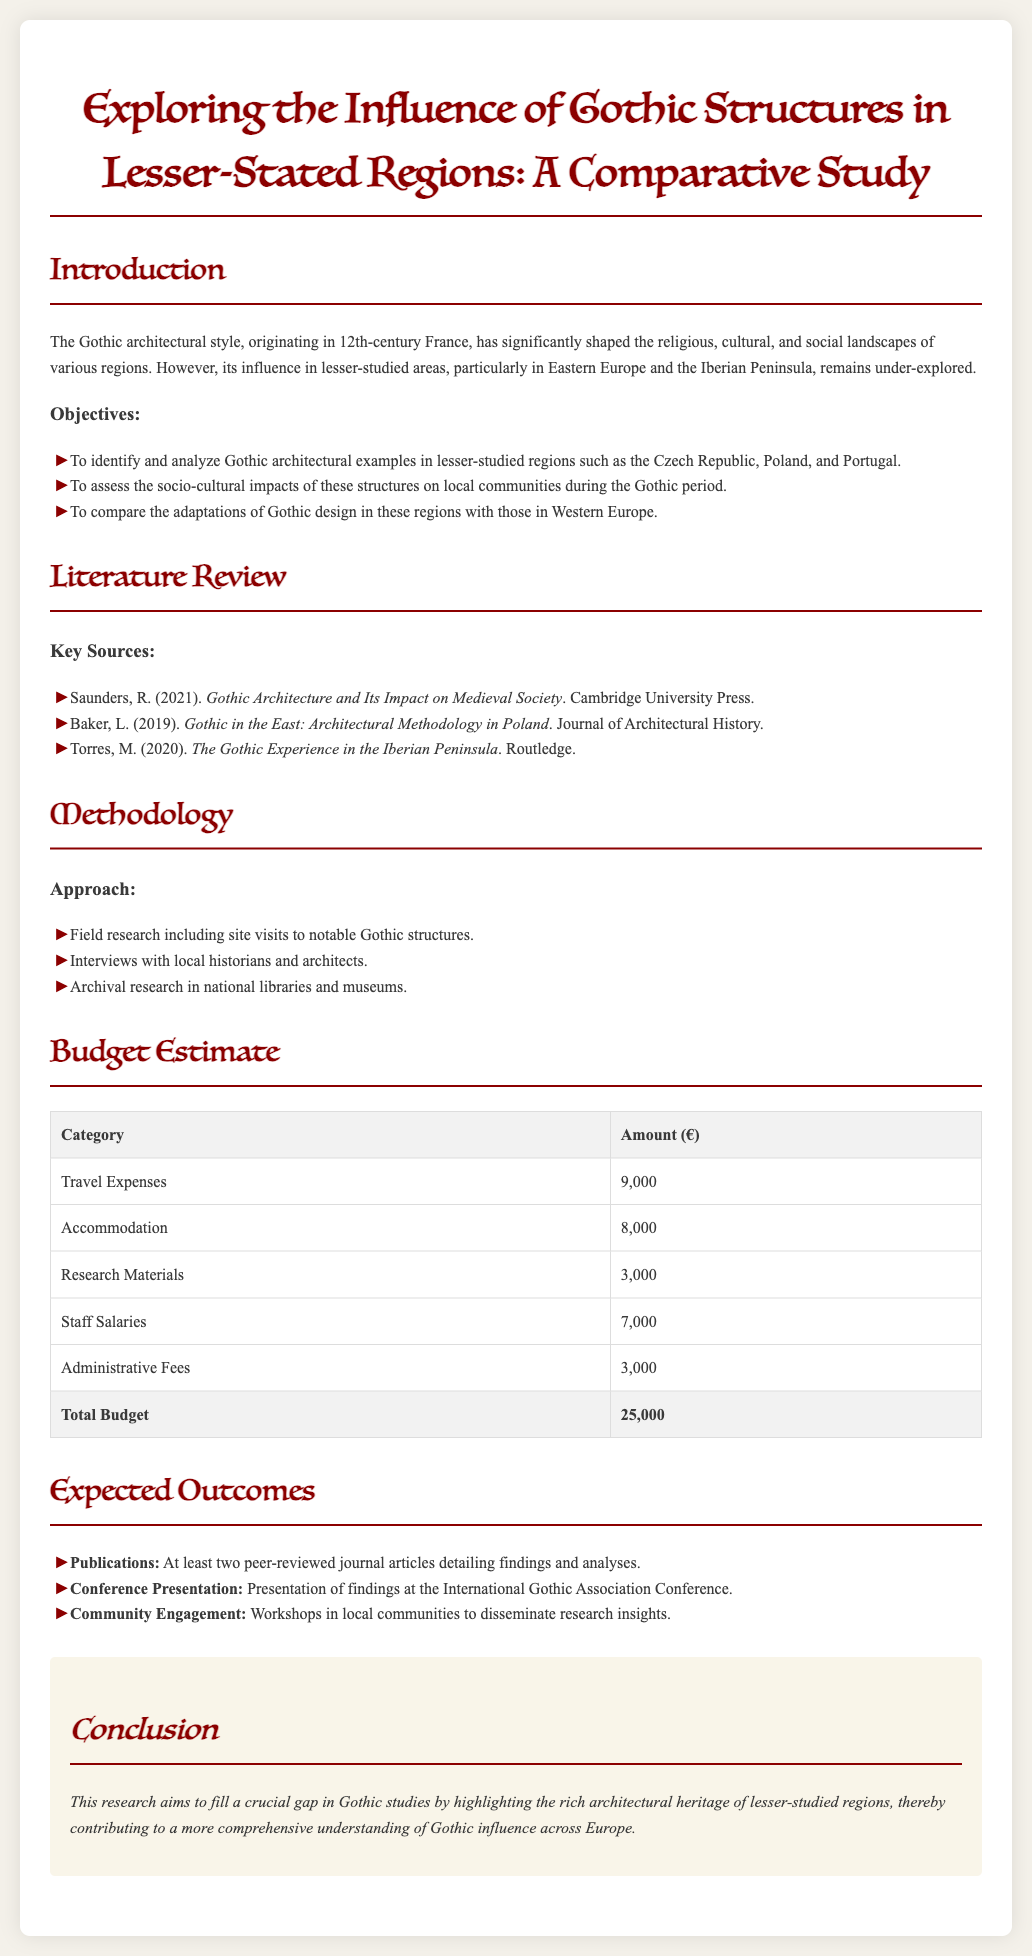What is the title of the proposal? The title of the proposal is stated at the top of the document in a prominent header.
Answer: Exploring the Influence of Gothic Structures in Lesser-Stated Regions: A Comparative Study How many key sources are listed in the literature review? The number of key sources is determined by counting the items in the listing under the literature review.
Answer: 3 What is the total budget estimate? The total budget estimate is provided in a table summarizing the financial breakdown of the proposal.
Answer: 25,000 Which regions are identified for analysis in the objectives? The regions are specifically named in the objectives section, detailing the focus areas of the research.
Answer: Czech Republic, Poland, Portugal What is one expected outcome of the research? The expected outcomes are listed, identifying specific deliverables for the research project.
Answer: Publications What methodology is proposed for data collection? The methodology section outlines various approaches to gathering data for the research project.
Answer: Field research What is the amount allocated for travel expenses? The budget table includes a specific entry for travel expenses, indicating the allocated amount.
Answer: 9,000 What community engagement activity is mentioned? The expected outcomes provide details about how the research will engage with local communities after completion.
Answer: Workshops in local communities 